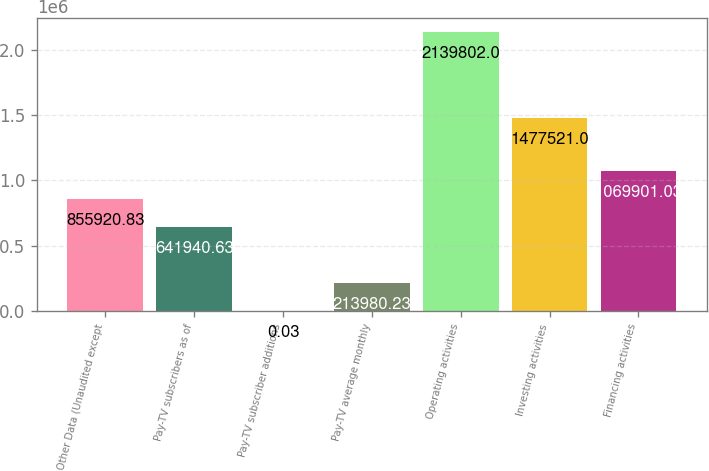<chart> <loc_0><loc_0><loc_500><loc_500><bar_chart><fcel>Other Data (Unaudited except<fcel>Pay-TV subscribers as of<fcel>Pay-TV subscriber additions<fcel>Pay-TV average monthly<fcel>Operating activities<fcel>Investing activities<fcel>Financing activities<nl><fcel>855921<fcel>641941<fcel>0.03<fcel>213980<fcel>2.1398e+06<fcel>1.47752e+06<fcel>1.0699e+06<nl></chart> 